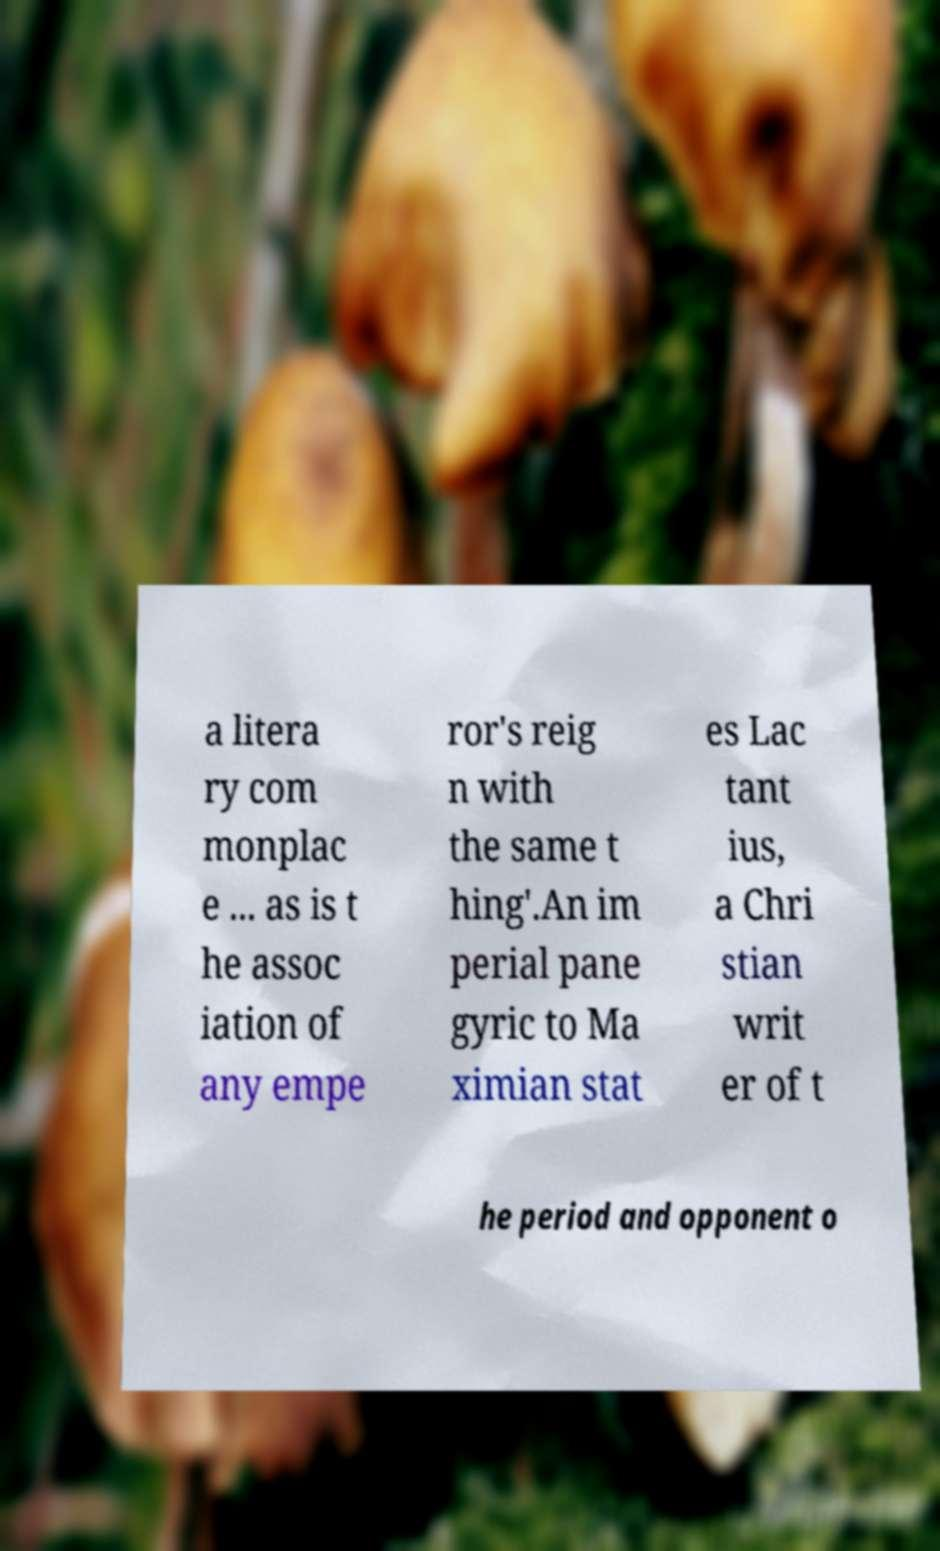Please identify and transcribe the text found in this image. a litera ry com monplac e ... as is t he assoc iation of any empe ror's reig n with the same t hing'.An im perial pane gyric to Ma ximian stat es Lac tant ius, a Chri stian writ er of t he period and opponent o 